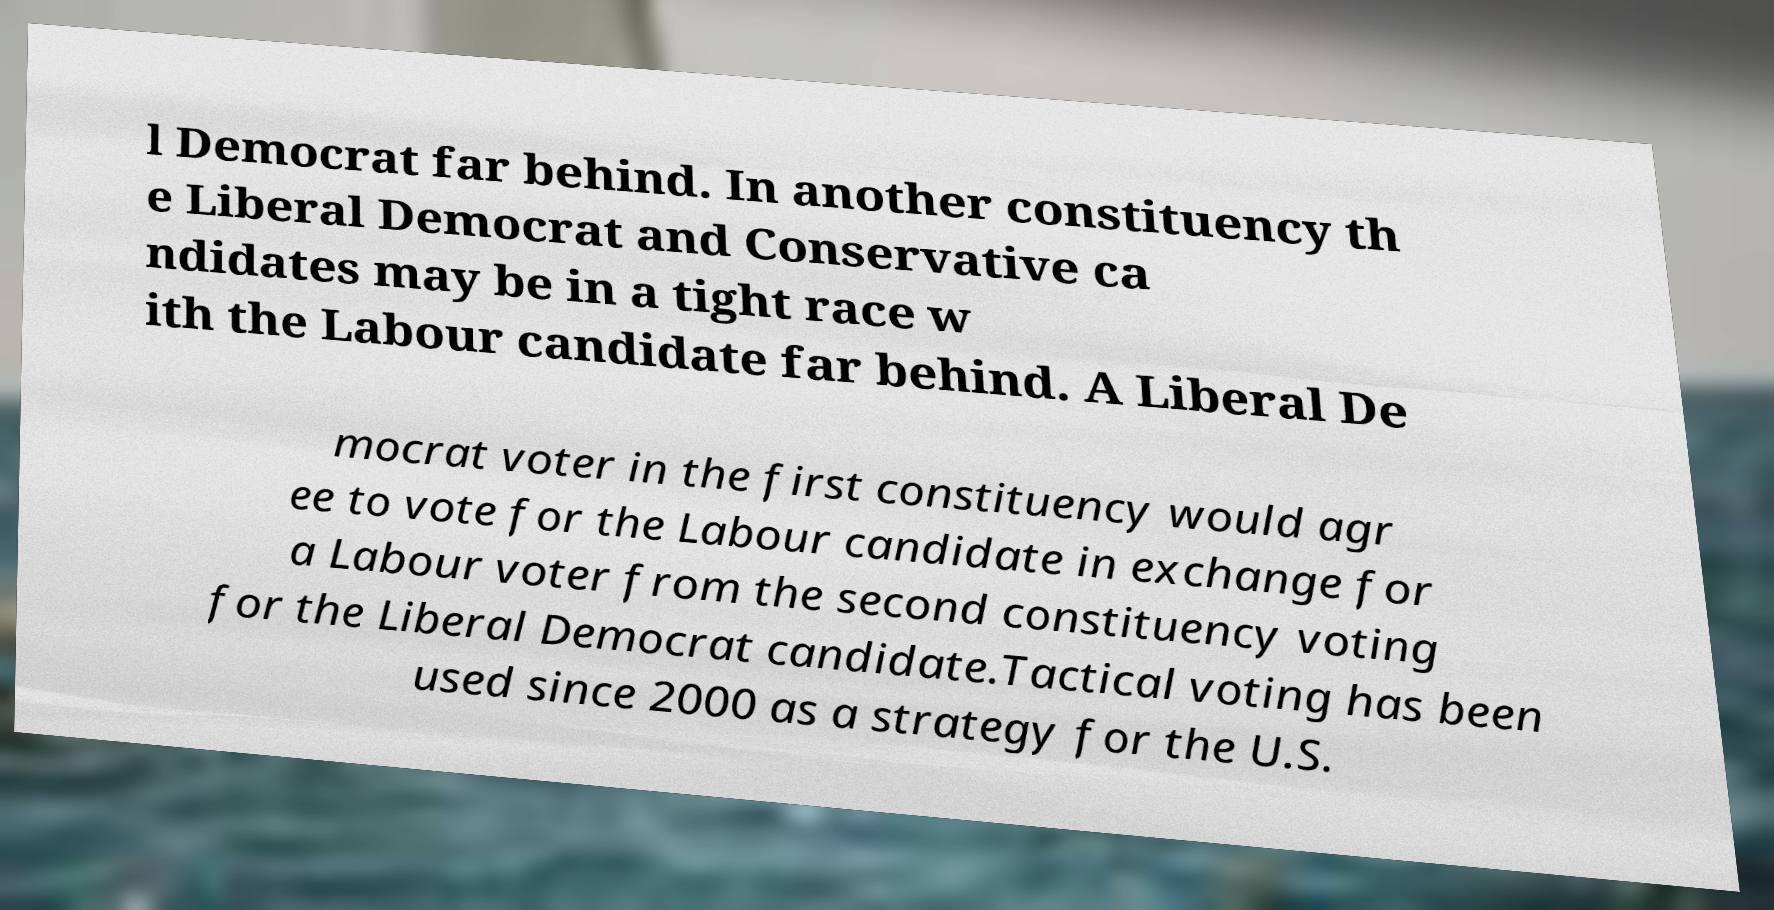Can you read and provide the text displayed in the image?This photo seems to have some interesting text. Can you extract and type it out for me? l Democrat far behind. In another constituency th e Liberal Democrat and Conservative ca ndidates may be in a tight race w ith the Labour candidate far behind. A Liberal De mocrat voter in the first constituency would agr ee to vote for the Labour candidate in exchange for a Labour voter from the second constituency voting for the Liberal Democrat candidate.Tactical voting has been used since 2000 as a strategy for the U.S. 